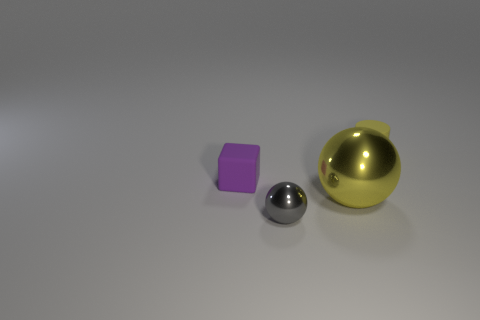How many tiny purple objects have the same material as the small yellow cylinder?
Your response must be concise. 1. There is a matte thing behind the tiny purple rubber cube; does it have the same color as the cube?
Your response must be concise. No. What number of gray things are big metal cubes or matte blocks?
Your answer should be very brief. 0. Are there any other things that have the same material as the tiny yellow cylinder?
Offer a terse response. Yes. Is the tiny object that is on the left side of the small shiny ball made of the same material as the tiny yellow cylinder?
Offer a terse response. Yes. How many objects are either big red cubes or small purple matte blocks that are on the left side of the small metal ball?
Your answer should be very brief. 1. There is a thing in front of the yellow object that is to the left of the small matte cylinder; how many yellow things are to the left of it?
Offer a very short reply. 0. Is the shape of the yellow thing that is in front of the yellow matte cylinder the same as  the yellow matte thing?
Your answer should be very brief. No. There is a metal sphere that is to the right of the gray sphere; is there a big metal ball to the left of it?
Keep it short and to the point. No. What number of small blue cylinders are there?
Provide a short and direct response. 0. 